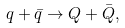<formula> <loc_0><loc_0><loc_500><loc_500>q + { \bar { q } } \rightarrow Q + { \bar { Q } } ,</formula> 